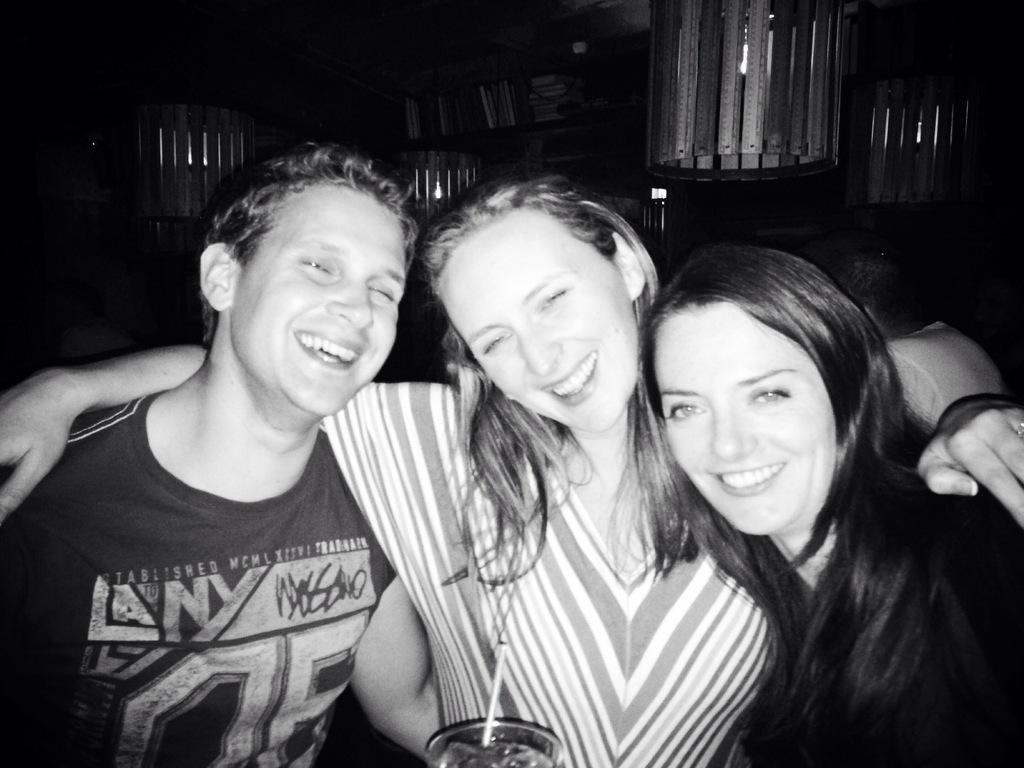How many people are in the image? There are three people in the center of the image. What is the facial expression of the people? The people are smiling. What can be seen in the background of the image? There is a shelf in the background of the image. What is visible at the top of the image? There are lights visible at the top of the image. What type of robin can be seen perched on the shelf in the image? There is no robin present in the image; it only features three people and a shelf in the background. 